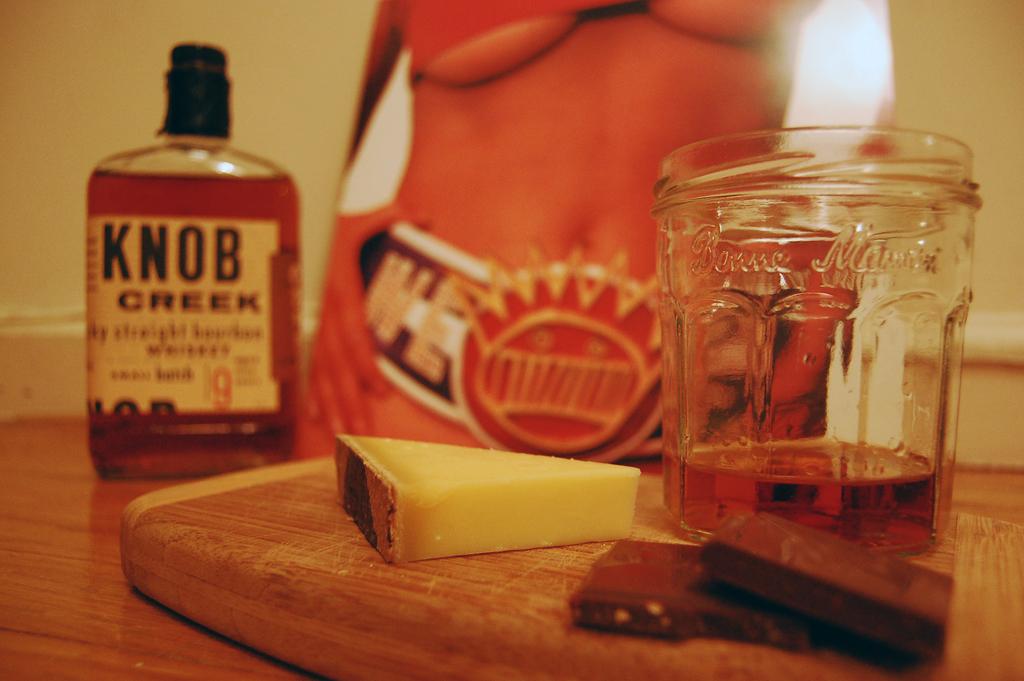What's the word that comes before creek on the bottle?
Provide a succinct answer. Knob. 